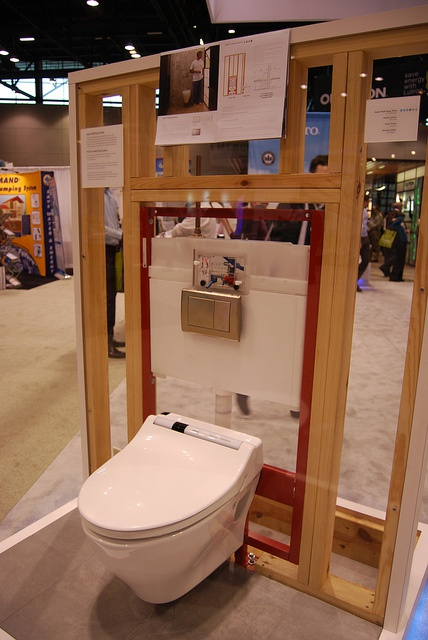Describe the objects in this image and their specific colors. I can see toilet in black, gray, and tan tones, people in black, gray, and maroon tones, people in black, gray, maroon, and brown tones, people in black, olive, maroon, and gray tones, and people in black, gray, and maroon tones in this image. 